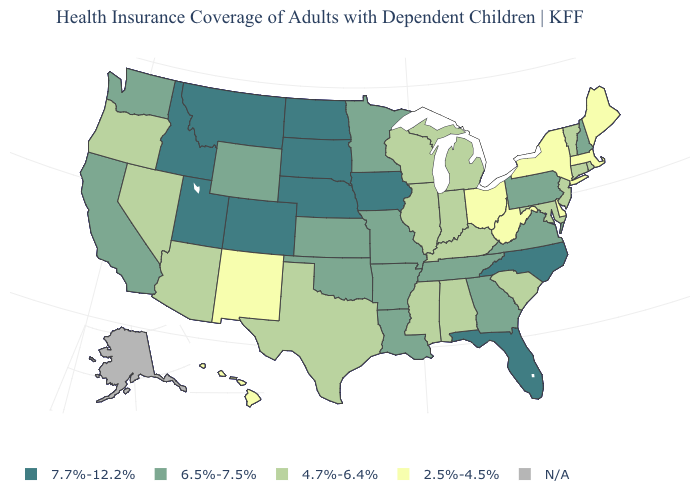Name the states that have a value in the range N/A?
Be succinct. Alaska. What is the highest value in states that border South Dakota?
Give a very brief answer. 7.7%-12.2%. What is the value of New York?
Concise answer only. 2.5%-4.5%. Name the states that have a value in the range N/A?
Concise answer only. Alaska. Does the map have missing data?
Keep it brief. Yes. What is the value of Maryland?
Quick response, please. 4.7%-6.4%. Does Washington have the highest value in the USA?
Be succinct. No. What is the value of Illinois?
Write a very short answer. 4.7%-6.4%. Which states have the lowest value in the MidWest?
Give a very brief answer. Ohio. Does Idaho have the highest value in the West?
Quick response, please. Yes. What is the lowest value in the West?
Write a very short answer. 2.5%-4.5%. Does Idaho have the highest value in the USA?
Be succinct. Yes. What is the value of North Dakota?
Keep it brief. 7.7%-12.2%. 